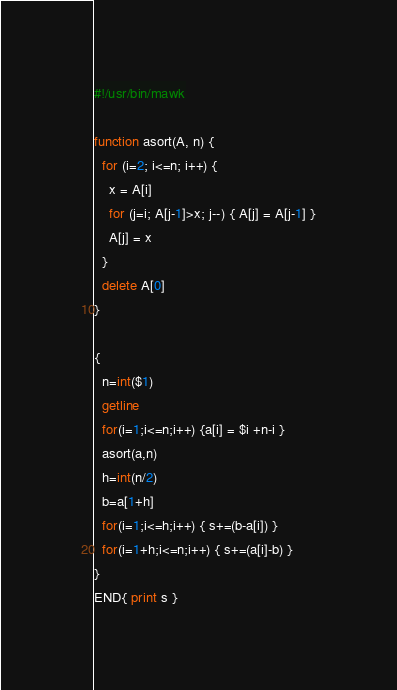Convert code to text. <code><loc_0><loc_0><loc_500><loc_500><_Awk_>#!/usr/bin/mawk

function asort(A, n) {
  for (i=2; i<=n; i++) {
    x = A[i]
    for (j=i; A[j-1]>x; j--) { A[j] = A[j-1] }
    A[j] = x
  }
  delete A[0]
}

{
  n=int($1)
  getline
  for(i=1;i<=n;i++) {a[i] = $i +n-i }
  asort(a,n)
  h=int(n/2)
  b=a[1+h]
  for(i=1;i<=h;i++) { s+=(b-a[i]) }
  for(i=1+h;i<=n;i++) { s+=(a[i]-b) }
}
END{ print s }
</code> 